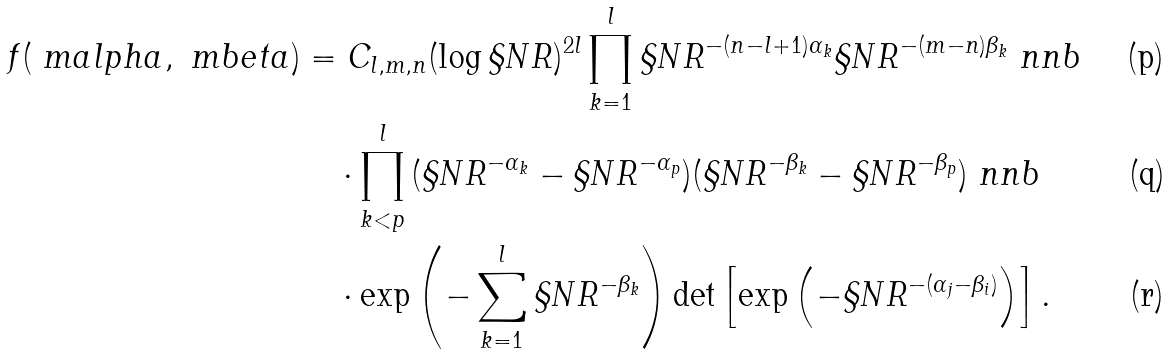<formula> <loc_0><loc_0><loc_500><loc_500>f ( \ m a l p h a , \ m b e t a ) & = C _ { l , m , n } ( \log \S N R ) ^ { 2 l } \prod _ { k = 1 } ^ { l } \S N R ^ { - ( n - l + 1 ) \alpha _ { k } } \S N R ^ { - ( m - n ) \beta _ { k } } \ n n b \\ & \quad \cdot \prod _ { k < p } ^ { l } { ( \S N R ^ { - \alpha _ { k } } - \S N R ^ { - \alpha _ { p } } ) } { ( \S N R ^ { - \beta _ { k } } - \S N R ^ { - \beta _ { p } } ) } \ n n b \\ & \quad \cdot \exp \left ( - \sum _ { k = 1 } ^ { l } \S N R ^ { - \beta _ { k } } \right ) \det \left [ \exp \left ( - \S N R ^ { - ( \alpha _ { j } - \beta _ { i } ) } \right ) \right ] .</formula> 